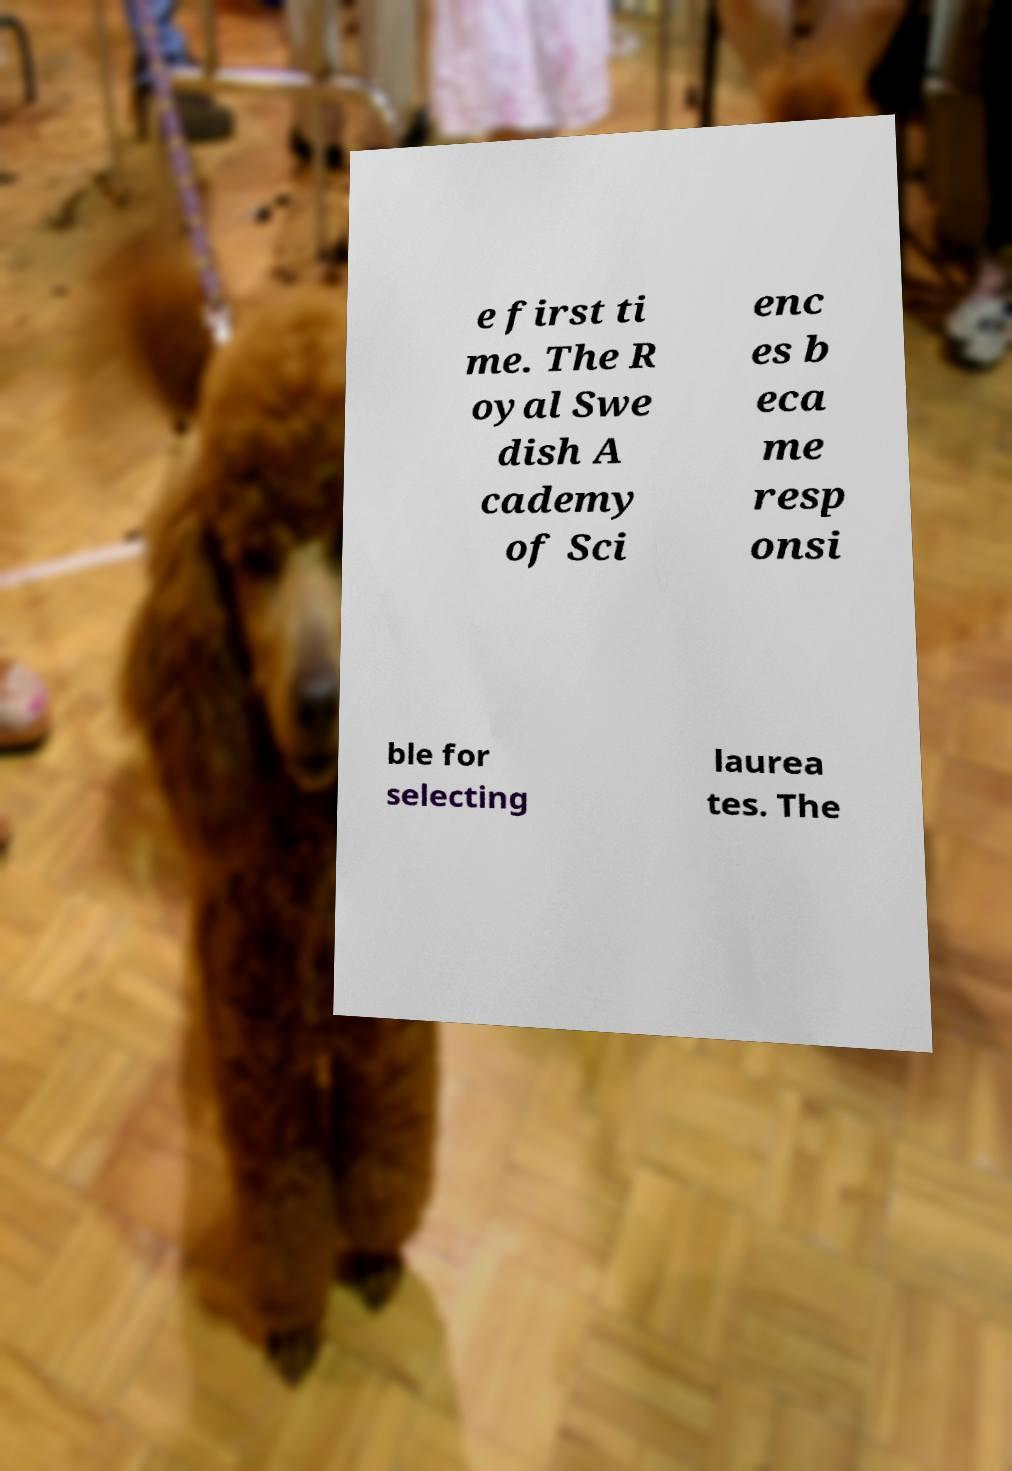Please identify and transcribe the text found in this image. e first ti me. The R oyal Swe dish A cademy of Sci enc es b eca me resp onsi ble for selecting laurea tes. The 